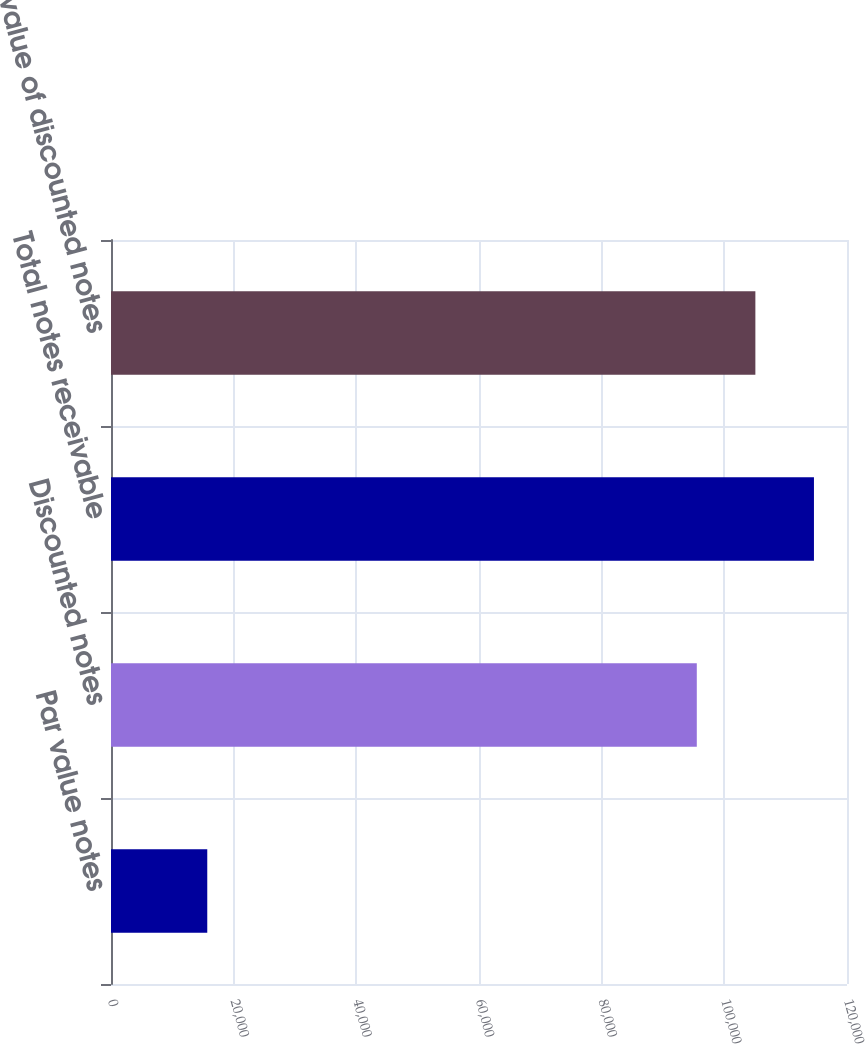<chart> <loc_0><loc_0><loc_500><loc_500><bar_chart><fcel>Par value notes<fcel>Discounted notes<fcel>Total notes receivable<fcel>Face value of discounted notes<nl><fcel>15695<fcel>95510<fcel>114612<fcel>105061<nl></chart> 